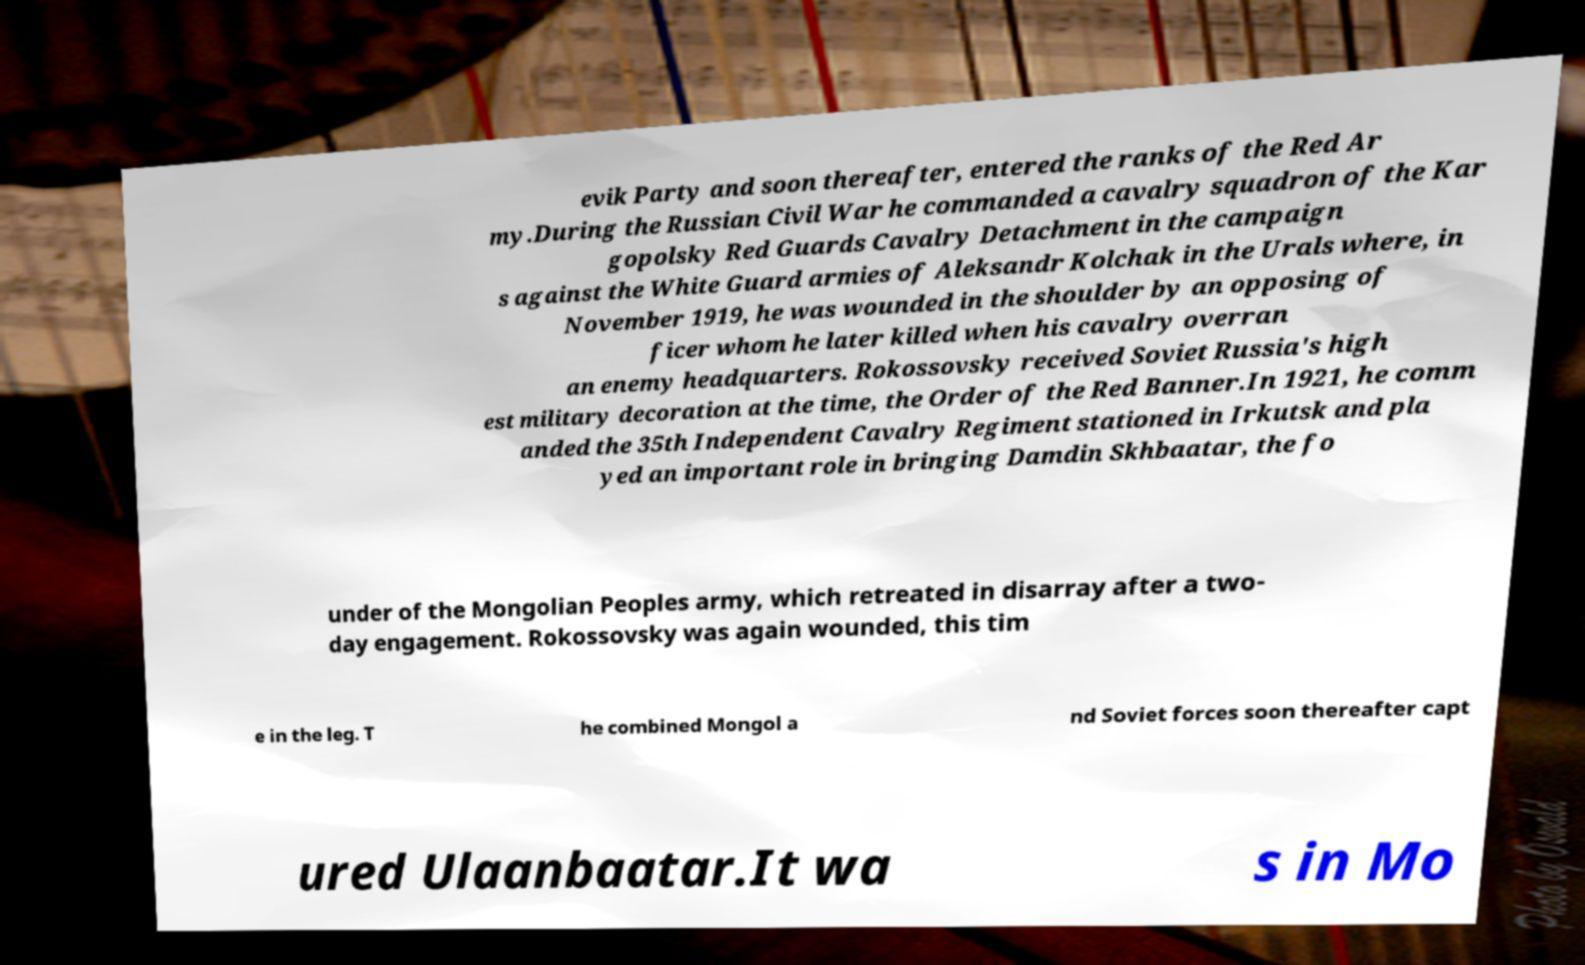Please read and relay the text visible in this image. What does it say? evik Party and soon thereafter, entered the ranks of the Red Ar my.During the Russian Civil War he commanded a cavalry squadron of the Kar gopolsky Red Guards Cavalry Detachment in the campaign s against the White Guard armies of Aleksandr Kolchak in the Urals where, in November 1919, he was wounded in the shoulder by an opposing of ficer whom he later killed when his cavalry overran an enemy headquarters. Rokossovsky received Soviet Russia's high est military decoration at the time, the Order of the Red Banner.In 1921, he comm anded the 35th Independent Cavalry Regiment stationed in Irkutsk and pla yed an important role in bringing Damdin Skhbaatar, the fo under of the Mongolian Peoples army, which retreated in disarray after a two- day engagement. Rokossovsky was again wounded, this tim e in the leg. T he combined Mongol a nd Soviet forces soon thereafter capt ured Ulaanbaatar.It wa s in Mo 